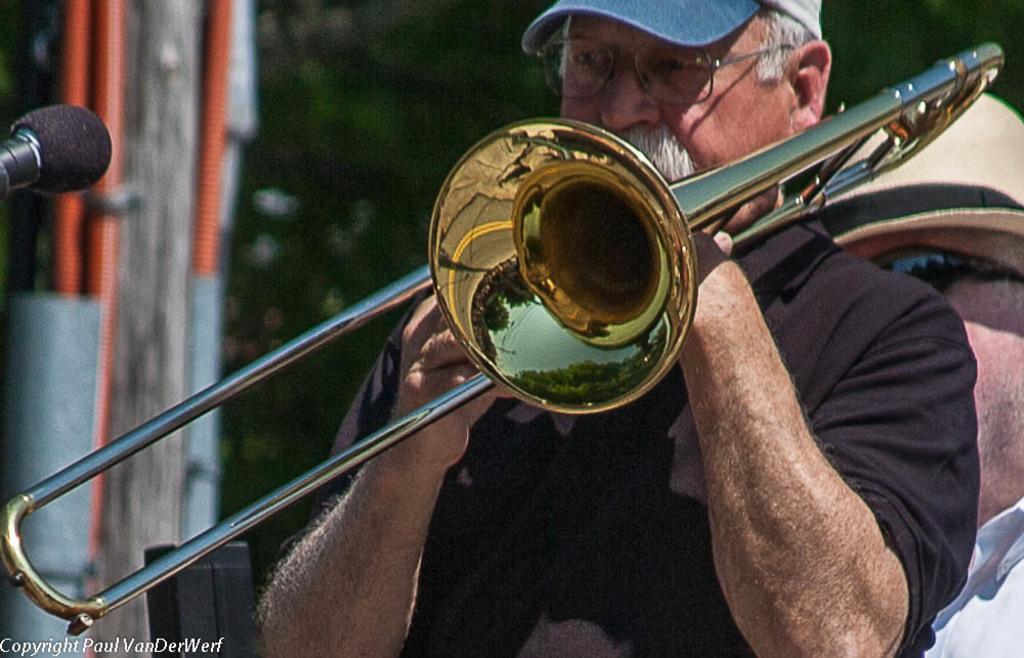Could you give a brief overview of what you see in this image? This image is taken outdoors. In the background there is a tree. On the left side of the image there is a pole and there is a mic. On the right side of the image there are two men and a man is holding a trampoline in his hands and playing music. 